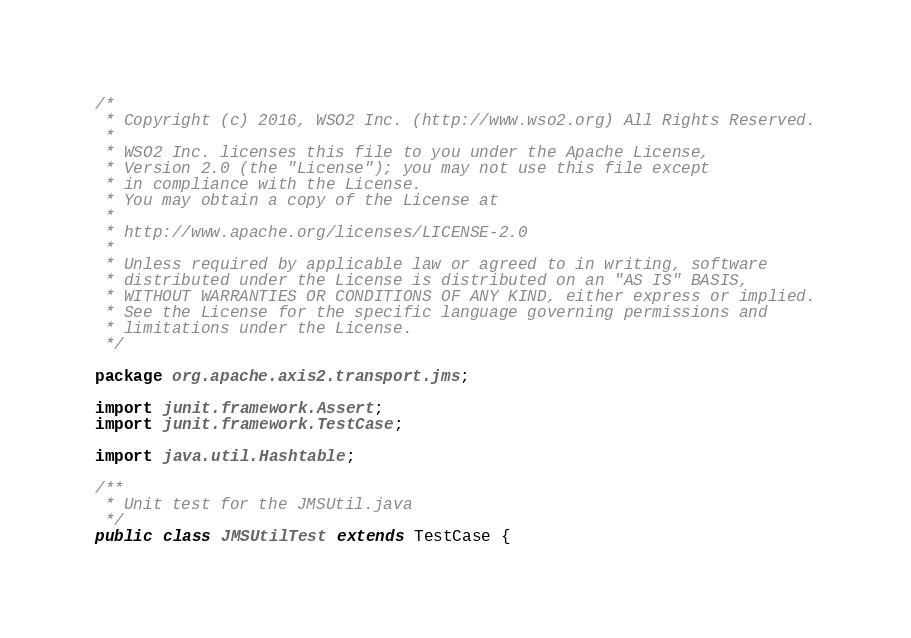Convert code to text. <code><loc_0><loc_0><loc_500><loc_500><_Java_>/*
 * Copyright (c) 2016, WSO2 Inc. (http://www.wso2.org) All Rights Reserved.
 *
 * WSO2 Inc. licenses this file to you under the Apache License, 
 * Version 2.0 (the "License"); you may not use this file except 
 * in compliance with the License.
 * You may obtain a copy of the License at
 *
 * http://www.apache.org/licenses/LICENSE-2.0
 *
 * Unless required by applicable law or agreed to in writing, software
 * distributed under the License is distributed on an "AS IS" BASIS,
 * WITHOUT WARRANTIES OR CONDITIONS OF ANY KIND, either express or implied.
 * See the License for the specific language governing permissions and
 * limitations under the License.
 */

package org.apache.axis2.transport.jms;

import junit.framework.Assert;
import junit.framework.TestCase;

import java.util.Hashtable;

/**
 * Unit test for the JMSUtil.java
 */
public class JMSUtilTest extends TestCase {
</code> 